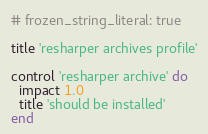<code> <loc_0><loc_0><loc_500><loc_500><_Ruby_># frozen_string_literal: true

title 'resharper archives profile'

control 'resharper archive' do
  impact 1.0
  title 'should be installed'
end
</code> 